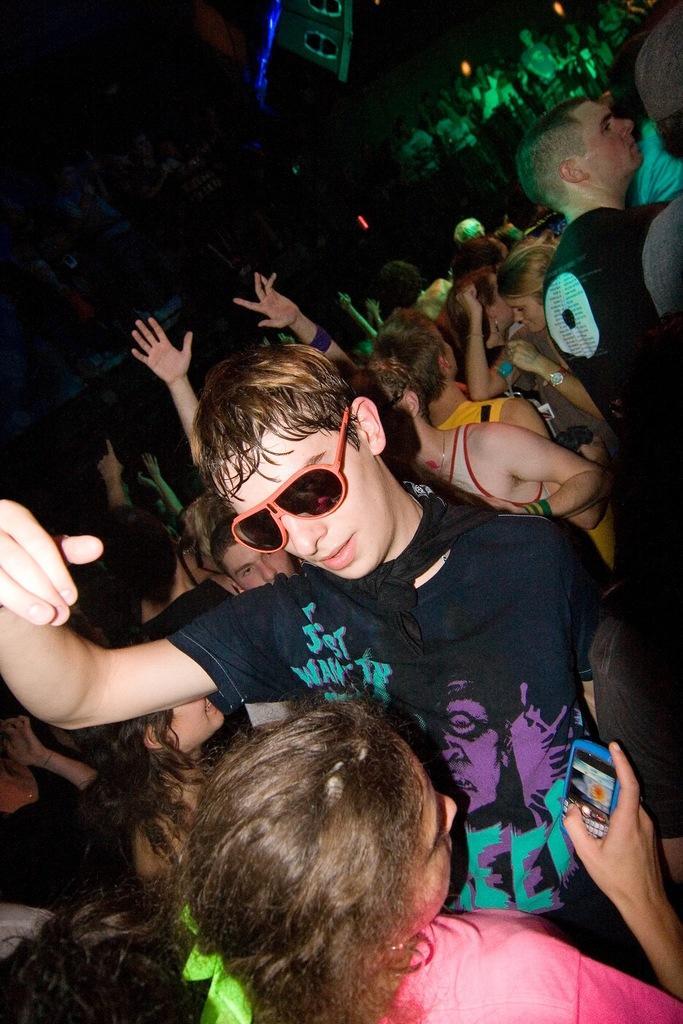Describe this image in one or two sentences. In this picture there is a man who is wearing spectacle, t-shirt and trouser. In front of him there is a woman who is looking in the mobile phone. In the back I can see many peoples were dancing. In the top right corner I can see some people were standing on the stage near to the drums. In the top left corner I can see the darkness. 